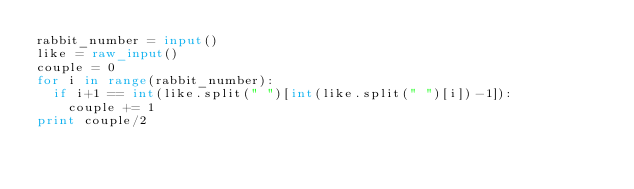Convert code to text. <code><loc_0><loc_0><loc_500><loc_500><_Python_>rabbit_number = input()
like = raw_input()
couple = 0
for i in range(rabbit_number):
	if i+1 == int(like.split(" ")[int(like.split(" ")[i])-1]):
		couple += 1
print couple/2</code> 